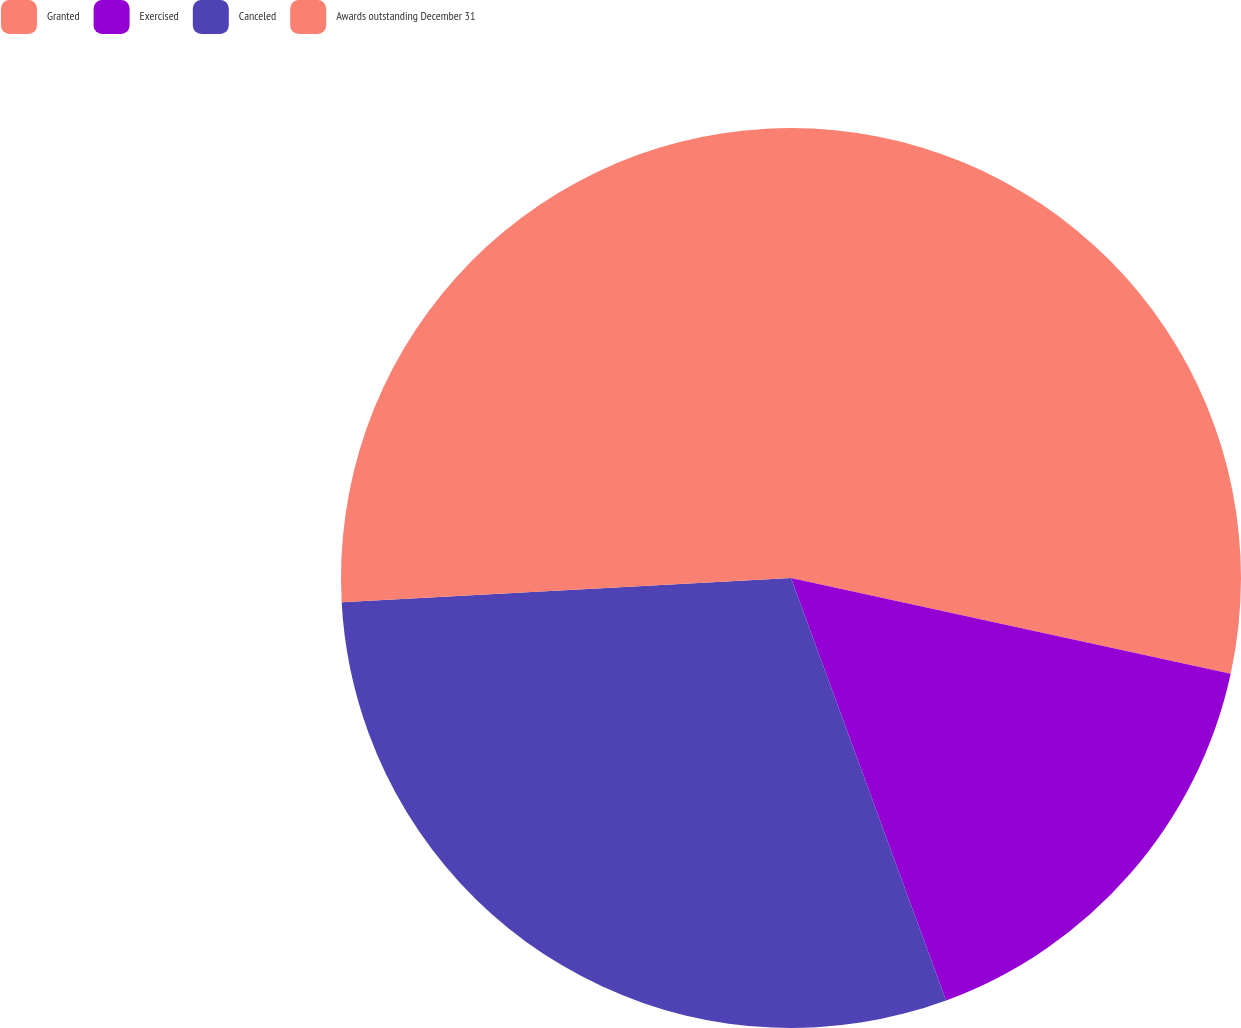Convert chart to OTSL. <chart><loc_0><loc_0><loc_500><loc_500><pie_chart><fcel>Granted<fcel>Exercised<fcel>Canceled<fcel>Awards outstanding December 31<nl><fcel>28.41%<fcel>15.99%<fcel>29.74%<fcel>25.86%<nl></chart> 